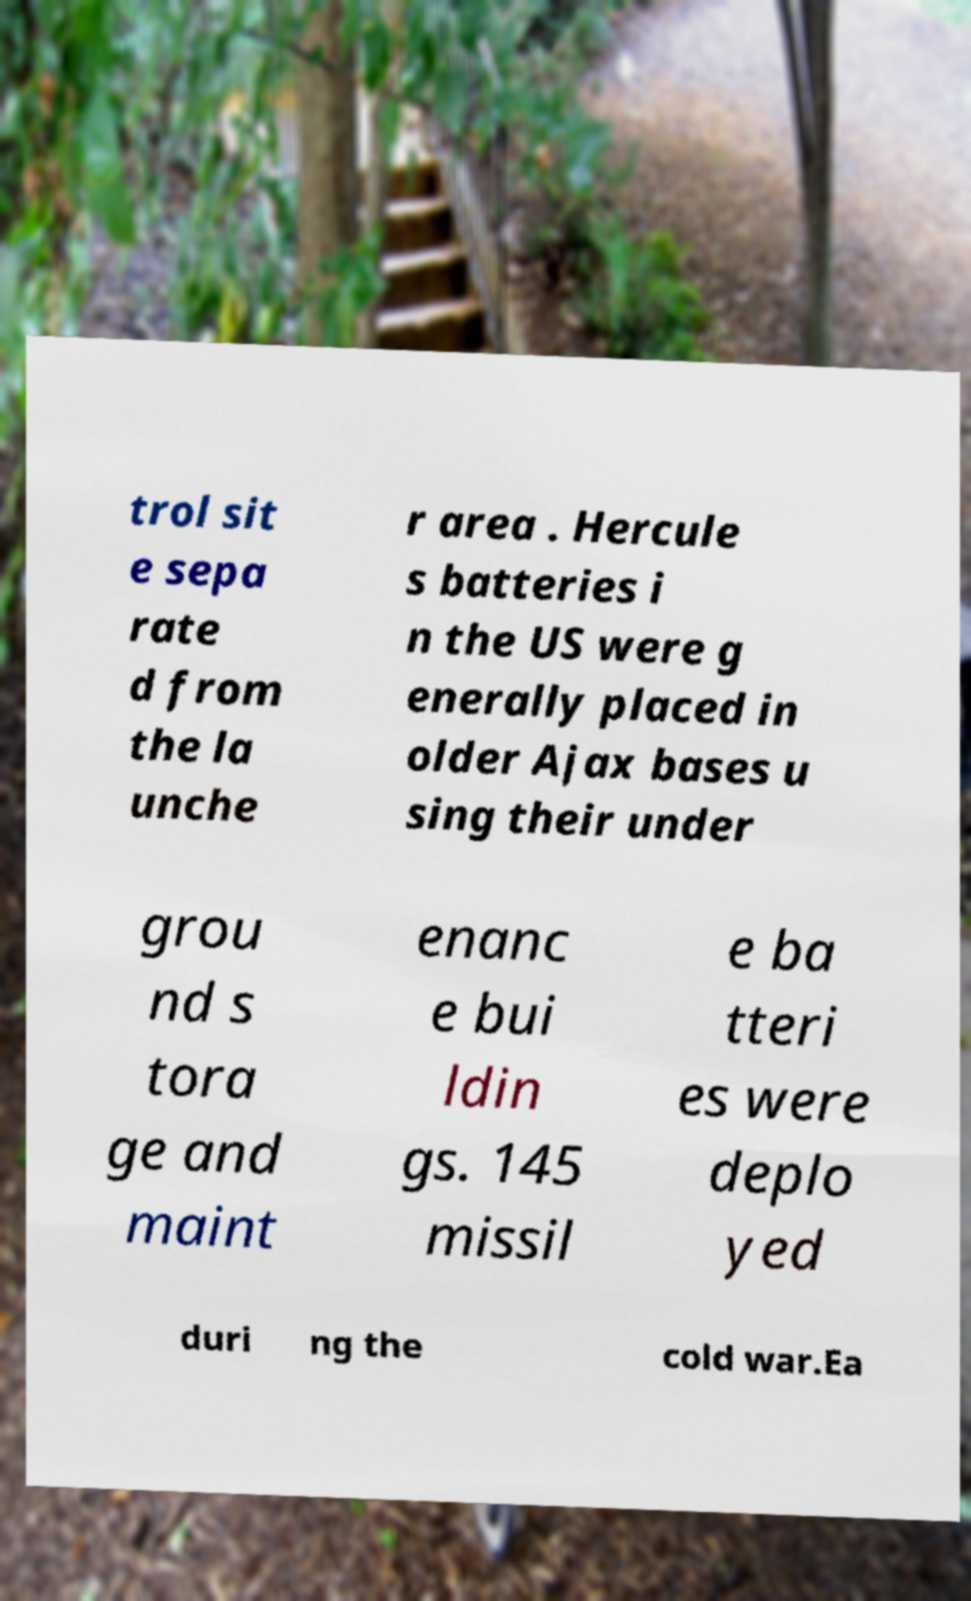Can you read and provide the text displayed in the image?This photo seems to have some interesting text. Can you extract and type it out for me? trol sit e sepa rate d from the la unche r area . Hercule s batteries i n the US were g enerally placed in older Ajax bases u sing their under grou nd s tora ge and maint enanc e bui ldin gs. 145 missil e ba tteri es were deplo yed duri ng the cold war.Ea 